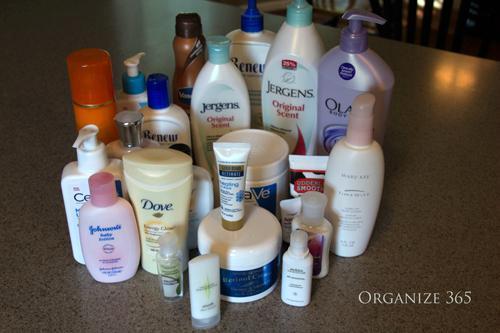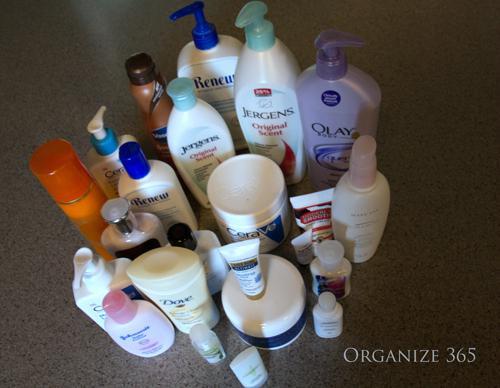The first image is the image on the left, the second image is the image on the right. Analyze the images presented: Is the assertion "The image to the right appears to be all the same brand name lotion, but different scents." valid? Answer yes or no. No. 